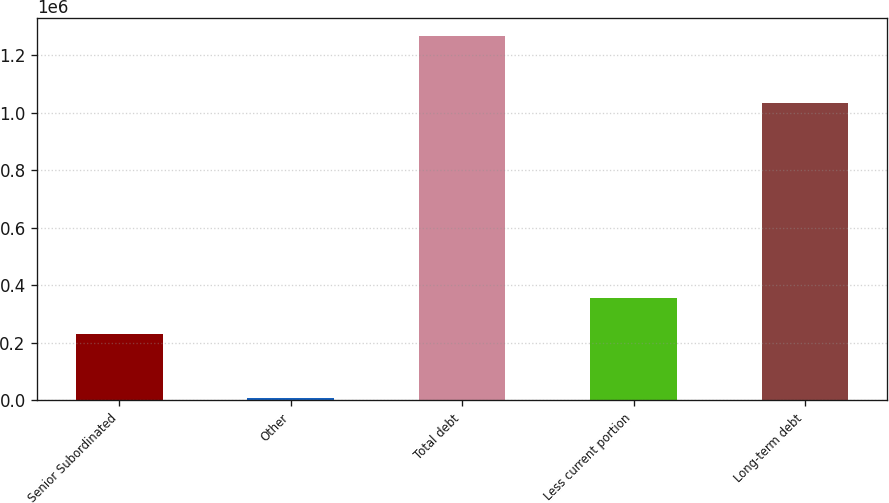<chart> <loc_0><loc_0><loc_500><loc_500><bar_chart><fcel>Senior Subordinated<fcel>Other<fcel>Total debt<fcel>Less current portion<fcel>Long-term debt<nl><fcel>230000<fcel>8516<fcel>1.26752e+06<fcel>355900<fcel>1.03369e+06<nl></chart> 